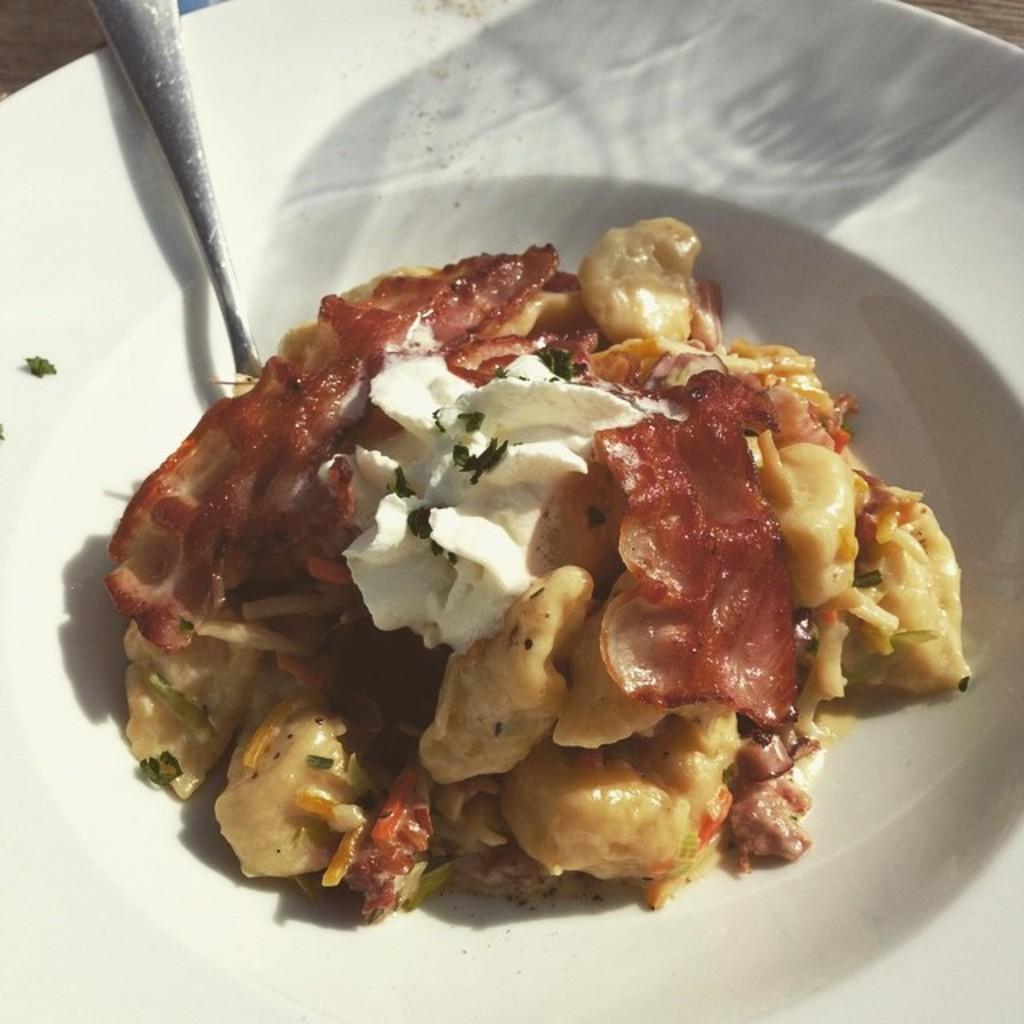How would you summarize this image in a sentence or two? In this picture we can see a plate and on plate we have some food item i think this is a spoon. 